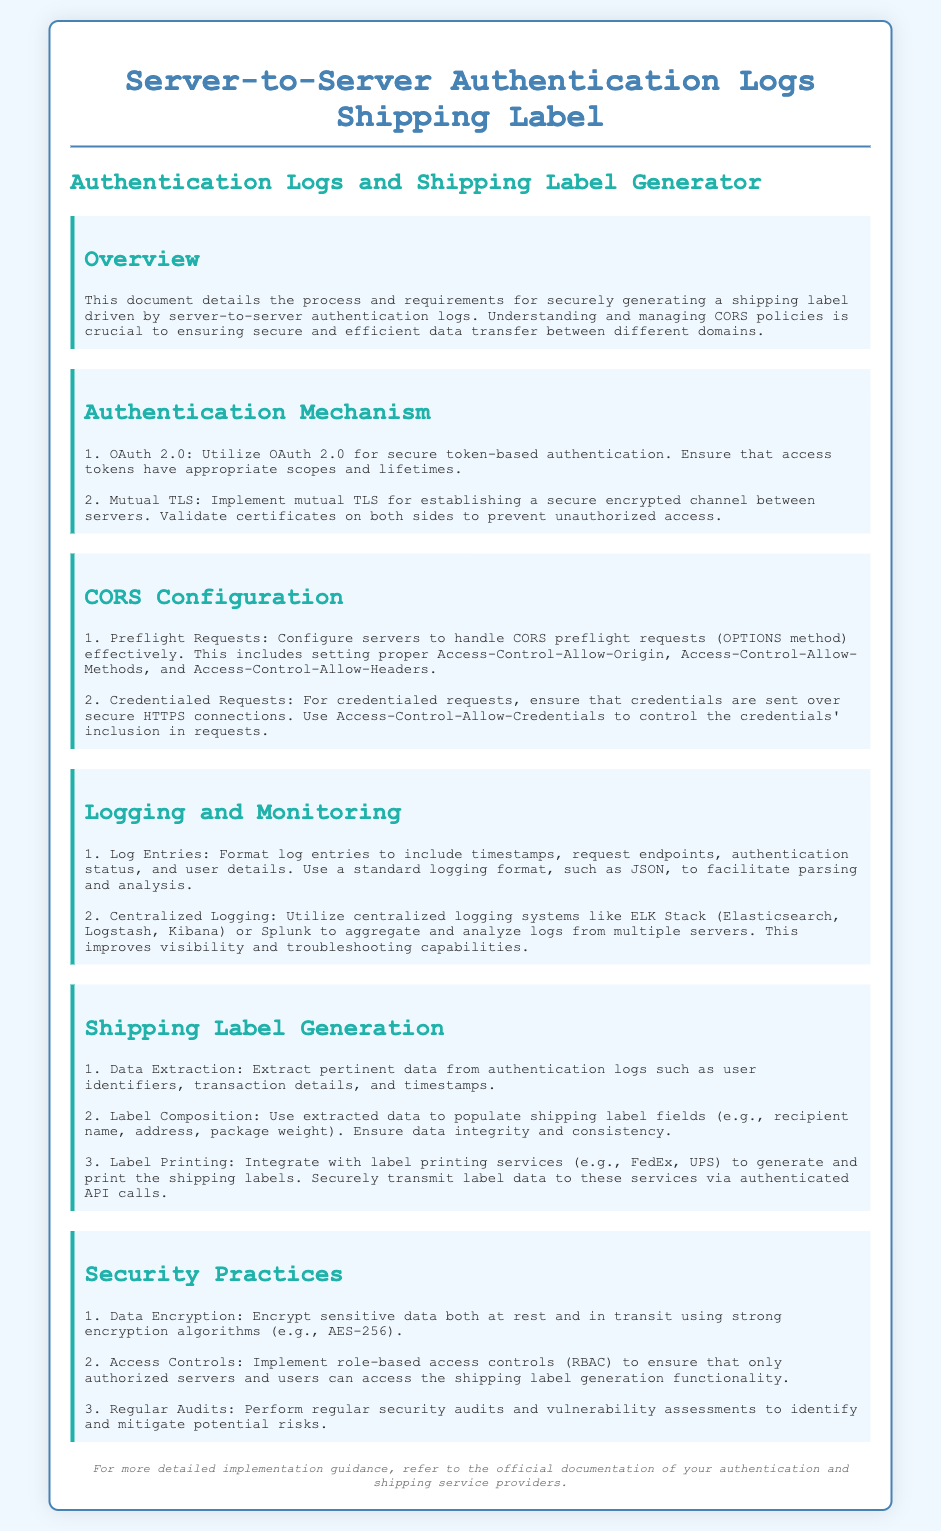What is the title of the document? The title of the document is stated at the beginning, summarizing its focus on server-to-server authentication logs.
Answer: Server-to-Server Authentication Logs Shipping Label What is the first authentication mechanism mentioned? The document lists authentication mechanisms, starting with the first one as described in the section.
Answer: OAuth 2.0 Which TLS implementation is recommended? The authentication mechanism section specifies a particular type of TLS to enhance security.
Answer: Mutual TLS What color represents the footer text? The document describes the style characteristics of the footer, including its color.
Answer: #777 What should be enabled for credentialed requests? The document outlines necessary configurations for handling credentialed requests related to security.
Answer: Access-Control-Allow-Credentials What data extraction should be performed for shipping labels? The shipping label generation section emphasizes particular types of data to extract from logs.
Answer: User identifiers, transaction details, timestamps Which logging system is suggested for centralized logging? The logging and monitoring section recommends specific systems for log aggregation and analysis.
Answer: ELK Stack What encryption algorithm is recommended for sensitive data? The security practices section details the encryption methods appropriate for securing data.
Answer: AES-256 What is one of the security practices mentioned? The document emphasizes several security practices that enhance the overall security posture.
Answer: Regular Audits 